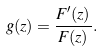Convert formula to latex. <formula><loc_0><loc_0><loc_500><loc_500>g ( z ) = \frac { F ^ { \prime } ( z ) } { F ( z ) } .</formula> 